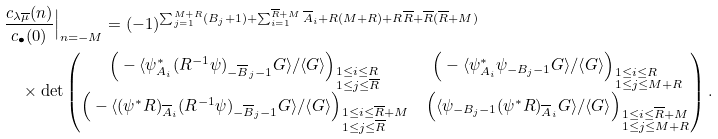Convert formula to latex. <formula><loc_0><loc_0><loc_500><loc_500>& \frac { c _ { \lambda \overline { \mu } } ( n ) } { c _ { \bullet } ( 0 ) } \Big | _ { n = - M } = ( - 1 ) ^ { \sum _ { j = 1 } ^ { M + R } ( B _ { j } + 1 ) + \sum _ { i = 1 } ^ { \overline { R } + M } \overline { A } _ { i } + R ( M + R ) + R \overline { R } + \overline { R } ( \overline { R } + M ) } \\ & \quad \times \det \begin{pmatrix} \Big ( - \langle \psi ^ { * } _ { A _ { i } } ( R ^ { - 1 } \psi ) _ { - \overline { B } _ { j } - 1 } G \rangle / \langle G \rangle \Big ) _ { \begin{subarray} { l } 1 \leq i \leq R \\ 1 \leq j \leq \overline { R } \end{subarray} } & \Big ( - \langle \psi ^ { * } _ { A _ { i } } \psi _ { - B _ { j } - 1 } G \rangle / \langle G \rangle \Big ) _ { \begin{subarray} { l } 1 \leq i \leq R \\ 1 \leq j \leq M + R \end{subarray} } \\ \Big ( - \langle ( \psi ^ { * } R ) _ { \overline { A } _ { i } } ( R ^ { - 1 } \psi ) _ { - \overline { B } _ { j } - 1 } G \rangle / \langle G \rangle \Big ) _ { \begin{subarray} { l } 1 \leq i \leq \overline { R } + M \\ 1 \leq j \leq \overline { R } \end{subarray} } & \Big ( \langle \psi _ { - B _ { j } - 1 } ( \psi ^ { * } R ) _ { \overline { A } _ { i } } G \rangle / \langle G \rangle \Big ) _ { \begin{subarray} { l } 1 \leq i \leq \overline { R } + M \\ 1 \leq j \leq M + R \end{subarray} } \end{pmatrix} .</formula> 